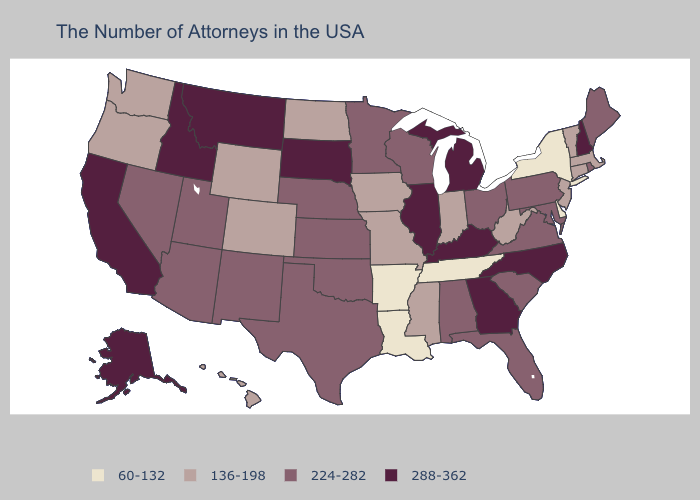What is the value of Wyoming?
Quick response, please. 136-198. Does Louisiana have the lowest value in the USA?
Short answer required. Yes. Among the states that border Michigan , which have the highest value?
Answer briefly. Ohio, Wisconsin. What is the value of Minnesota?
Answer briefly. 224-282. What is the value of Montana?
Concise answer only. 288-362. Which states have the lowest value in the USA?
Write a very short answer. New York, Delaware, Tennessee, Louisiana, Arkansas. Name the states that have a value in the range 60-132?
Give a very brief answer. New York, Delaware, Tennessee, Louisiana, Arkansas. Among the states that border Delaware , does Pennsylvania have the highest value?
Concise answer only. Yes. What is the value of Nebraska?
Be succinct. 224-282. Which states have the highest value in the USA?
Short answer required. New Hampshire, North Carolina, Georgia, Michigan, Kentucky, Illinois, South Dakota, Montana, Idaho, California, Alaska. Does New York have the lowest value in the Northeast?
Write a very short answer. Yes. Which states have the lowest value in the USA?
Write a very short answer. New York, Delaware, Tennessee, Louisiana, Arkansas. Does Kansas have the highest value in the MidWest?
Be succinct. No. Name the states that have a value in the range 136-198?
Concise answer only. Massachusetts, Vermont, Connecticut, New Jersey, West Virginia, Indiana, Mississippi, Missouri, Iowa, North Dakota, Wyoming, Colorado, Washington, Oregon, Hawaii. 